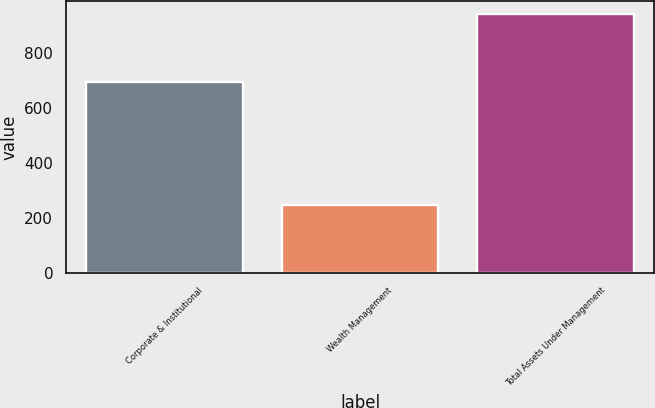<chart> <loc_0><loc_0><loc_500><loc_500><bar_chart><fcel>Corporate & Institutional<fcel>Wealth Management<fcel>Total Assets Under Management<nl><fcel>694<fcel>248.4<fcel>942.4<nl></chart> 